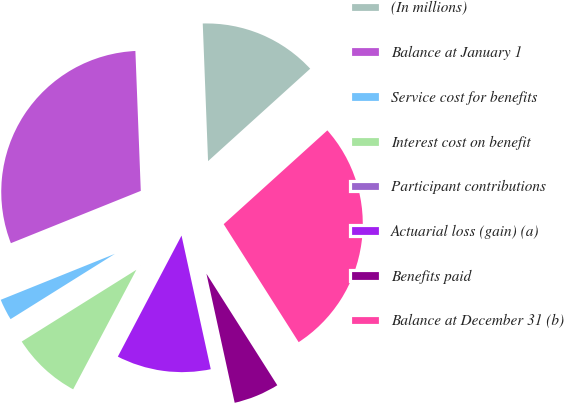Convert chart to OTSL. <chart><loc_0><loc_0><loc_500><loc_500><pie_chart><fcel>(In millions)<fcel>Balance at January 1<fcel>Service cost for benefits<fcel>Interest cost on benefit<fcel>Participant contributions<fcel>Actuarial loss (gain) (a)<fcel>Benefits paid<fcel>Balance at December 31 (b)<nl><fcel>13.91%<fcel>30.48%<fcel>2.81%<fcel>8.36%<fcel>0.03%<fcel>11.14%<fcel>5.58%<fcel>27.7%<nl></chart> 